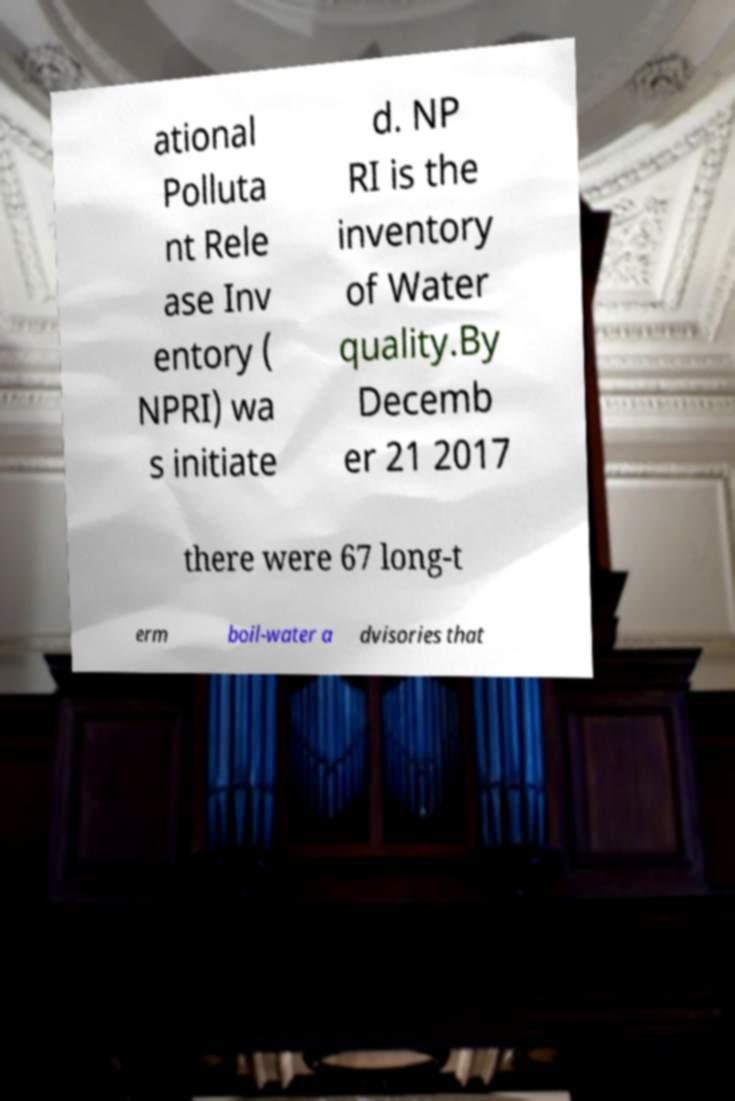Can you accurately transcribe the text from the provided image for me? ational Polluta nt Rele ase Inv entory ( NPRI) wa s initiate d. NP RI is the inventory of Water quality.By Decemb er 21 2017 there were 67 long-t erm boil-water a dvisories that 